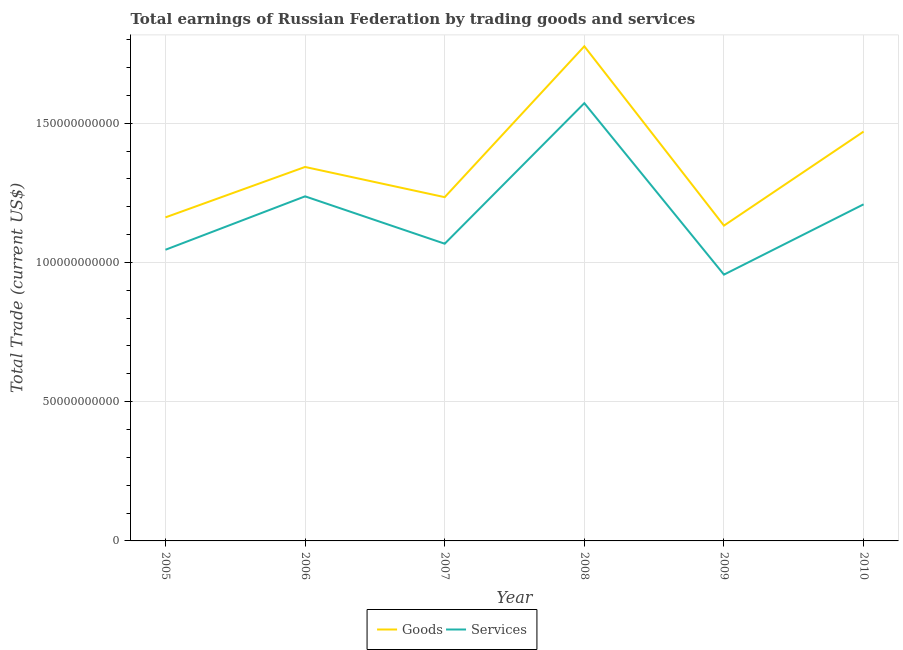How many different coloured lines are there?
Give a very brief answer. 2. Is the number of lines equal to the number of legend labels?
Keep it short and to the point. Yes. What is the amount earned by trading goods in 2010?
Provide a short and direct response. 1.47e+11. Across all years, what is the maximum amount earned by trading goods?
Give a very brief answer. 1.78e+11. Across all years, what is the minimum amount earned by trading goods?
Your response must be concise. 1.13e+11. What is the total amount earned by trading goods in the graph?
Make the answer very short. 8.12e+11. What is the difference between the amount earned by trading goods in 2007 and that in 2010?
Offer a terse response. -2.35e+1. What is the difference between the amount earned by trading goods in 2006 and the amount earned by trading services in 2010?
Keep it short and to the point. 1.34e+1. What is the average amount earned by trading services per year?
Make the answer very short. 1.18e+11. In the year 2010, what is the difference between the amount earned by trading services and amount earned by trading goods?
Your answer should be very brief. -2.61e+1. In how many years, is the amount earned by trading services greater than 90000000000 US$?
Provide a short and direct response. 6. What is the ratio of the amount earned by trading services in 2005 to that in 2007?
Keep it short and to the point. 0.98. Is the amount earned by trading goods in 2005 less than that in 2006?
Ensure brevity in your answer.  Yes. Is the difference between the amount earned by trading services in 2005 and 2009 greater than the difference between the amount earned by trading goods in 2005 and 2009?
Your response must be concise. Yes. What is the difference between the highest and the second highest amount earned by trading goods?
Keep it short and to the point. 3.06e+1. What is the difference between the highest and the lowest amount earned by trading goods?
Make the answer very short. 6.44e+1. In how many years, is the amount earned by trading services greater than the average amount earned by trading services taken over all years?
Your answer should be very brief. 3. Is the sum of the amount earned by trading goods in 2005 and 2008 greater than the maximum amount earned by trading services across all years?
Keep it short and to the point. Yes. Does the amount earned by trading services monotonically increase over the years?
Your response must be concise. No. How many lines are there?
Offer a very short reply. 2. What is the difference between two consecutive major ticks on the Y-axis?
Offer a very short reply. 5.00e+1. Does the graph contain any zero values?
Make the answer very short. No. Does the graph contain grids?
Provide a short and direct response. Yes. How are the legend labels stacked?
Keep it short and to the point. Horizontal. What is the title of the graph?
Offer a terse response. Total earnings of Russian Federation by trading goods and services. What is the label or title of the X-axis?
Provide a succinct answer. Year. What is the label or title of the Y-axis?
Your response must be concise. Total Trade (current US$). What is the Total Trade (current US$) of Goods in 2005?
Your answer should be compact. 1.16e+11. What is the Total Trade (current US$) of Services in 2005?
Ensure brevity in your answer.  1.05e+11. What is the Total Trade (current US$) in Goods in 2006?
Provide a short and direct response. 1.34e+11. What is the Total Trade (current US$) of Services in 2006?
Make the answer very short. 1.24e+11. What is the Total Trade (current US$) in Goods in 2007?
Your response must be concise. 1.23e+11. What is the Total Trade (current US$) of Services in 2007?
Make the answer very short. 1.07e+11. What is the Total Trade (current US$) in Goods in 2008?
Provide a succinct answer. 1.78e+11. What is the Total Trade (current US$) in Services in 2008?
Offer a very short reply. 1.57e+11. What is the Total Trade (current US$) in Goods in 2009?
Your answer should be very brief. 1.13e+11. What is the Total Trade (current US$) in Services in 2009?
Keep it short and to the point. 9.56e+1. What is the Total Trade (current US$) of Goods in 2010?
Provide a short and direct response. 1.47e+11. What is the Total Trade (current US$) of Services in 2010?
Offer a very short reply. 1.21e+11. Across all years, what is the maximum Total Trade (current US$) of Goods?
Your response must be concise. 1.78e+11. Across all years, what is the maximum Total Trade (current US$) of Services?
Your answer should be compact. 1.57e+11. Across all years, what is the minimum Total Trade (current US$) of Goods?
Keep it short and to the point. 1.13e+11. Across all years, what is the minimum Total Trade (current US$) in Services?
Provide a short and direct response. 9.56e+1. What is the total Total Trade (current US$) of Goods in the graph?
Offer a terse response. 8.12e+11. What is the total Total Trade (current US$) in Services in the graph?
Your answer should be compact. 7.09e+11. What is the difference between the Total Trade (current US$) in Goods in 2005 and that in 2006?
Your response must be concise. -1.81e+1. What is the difference between the Total Trade (current US$) in Services in 2005 and that in 2006?
Provide a short and direct response. -1.92e+1. What is the difference between the Total Trade (current US$) of Goods in 2005 and that in 2007?
Give a very brief answer. -7.26e+09. What is the difference between the Total Trade (current US$) of Services in 2005 and that in 2007?
Keep it short and to the point. -2.17e+09. What is the difference between the Total Trade (current US$) of Goods in 2005 and that in 2008?
Your answer should be compact. -6.14e+1. What is the difference between the Total Trade (current US$) in Services in 2005 and that in 2008?
Provide a short and direct response. -5.26e+1. What is the difference between the Total Trade (current US$) in Goods in 2005 and that in 2009?
Offer a very short reply. 2.95e+09. What is the difference between the Total Trade (current US$) in Services in 2005 and that in 2009?
Keep it short and to the point. 8.93e+09. What is the difference between the Total Trade (current US$) of Goods in 2005 and that in 2010?
Provide a short and direct response. -3.08e+1. What is the difference between the Total Trade (current US$) of Services in 2005 and that in 2010?
Offer a terse response. -1.63e+1. What is the difference between the Total Trade (current US$) in Goods in 2006 and that in 2007?
Ensure brevity in your answer.  1.08e+1. What is the difference between the Total Trade (current US$) in Services in 2006 and that in 2007?
Your response must be concise. 1.70e+1. What is the difference between the Total Trade (current US$) in Goods in 2006 and that in 2008?
Provide a succinct answer. -4.33e+1. What is the difference between the Total Trade (current US$) of Services in 2006 and that in 2008?
Give a very brief answer. -3.35e+1. What is the difference between the Total Trade (current US$) of Goods in 2006 and that in 2009?
Offer a terse response. 2.11e+1. What is the difference between the Total Trade (current US$) in Services in 2006 and that in 2009?
Make the answer very short. 2.81e+1. What is the difference between the Total Trade (current US$) in Goods in 2006 and that in 2010?
Your answer should be very brief. -1.27e+1. What is the difference between the Total Trade (current US$) of Services in 2006 and that in 2010?
Make the answer very short. 2.86e+09. What is the difference between the Total Trade (current US$) of Goods in 2007 and that in 2008?
Make the answer very short. -5.42e+1. What is the difference between the Total Trade (current US$) in Services in 2007 and that in 2008?
Offer a terse response. -5.05e+1. What is the difference between the Total Trade (current US$) of Goods in 2007 and that in 2009?
Your answer should be very brief. 1.02e+1. What is the difference between the Total Trade (current US$) in Services in 2007 and that in 2009?
Your answer should be very brief. 1.11e+1. What is the difference between the Total Trade (current US$) of Goods in 2007 and that in 2010?
Offer a very short reply. -2.35e+1. What is the difference between the Total Trade (current US$) in Services in 2007 and that in 2010?
Provide a short and direct response. -1.41e+1. What is the difference between the Total Trade (current US$) in Goods in 2008 and that in 2009?
Keep it short and to the point. 6.44e+1. What is the difference between the Total Trade (current US$) of Services in 2008 and that in 2009?
Your response must be concise. 6.16e+1. What is the difference between the Total Trade (current US$) in Goods in 2008 and that in 2010?
Make the answer very short. 3.06e+1. What is the difference between the Total Trade (current US$) in Services in 2008 and that in 2010?
Your answer should be very brief. 3.63e+1. What is the difference between the Total Trade (current US$) of Goods in 2009 and that in 2010?
Keep it short and to the point. -3.38e+1. What is the difference between the Total Trade (current US$) of Services in 2009 and that in 2010?
Your answer should be very brief. -2.52e+1. What is the difference between the Total Trade (current US$) of Goods in 2005 and the Total Trade (current US$) of Services in 2006?
Offer a terse response. -7.56e+09. What is the difference between the Total Trade (current US$) of Goods in 2005 and the Total Trade (current US$) of Services in 2007?
Ensure brevity in your answer.  9.46e+09. What is the difference between the Total Trade (current US$) of Goods in 2005 and the Total Trade (current US$) of Services in 2008?
Give a very brief answer. -4.10e+1. What is the difference between the Total Trade (current US$) in Goods in 2005 and the Total Trade (current US$) in Services in 2009?
Keep it short and to the point. 2.06e+1. What is the difference between the Total Trade (current US$) in Goods in 2005 and the Total Trade (current US$) in Services in 2010?
Keep it short and to the point. -4.69e+09. What is the difference between the Total Trade (current US$) of Goods in 2006 and the Total Trade (current US$) of Services in 2007?
Your response must be concise. 2.76e+1. What is the difference between the Total Trade (current US$) of Goods in 2006 and the Total Trade (current US$) of Services in 2008?
Offer a terse response. -2.29e+1. What is the difference between the Total Trade (current US$) of Goods in 2006 and the Total Trade (current US$) of Services in 2009?
Make the answer very short. 3.87e+1. What is the difference between the Total Trade (current US$) in Goods in 2006 and the Total Trade (current US$) in Services in 2010?
Ensure brevity in your answer.  1.34e+1. What is the difference between the Total Trade (current US$) of Goods in 2007 and the Total Trade (current US$) of Services in 2008?
Your answer should be compact. -3.38e+1. What is the difference between the Total Trade (current US$) of Goods in 2007 and the Total Trade (current US$) of Services in 2009?
Offer a terse response. 2.78e+1. What is the difference between the Total Trade (current US$) of Goods in 2007 and the Total Trade (current US$) of Services in 2010?
Your response must be concise. 2.57e+09. What is the difference between the Total Trade (current US$) of Goods in 2008 and the Total Trade (current US$) of Services in 2009?
Your answer should be compact. 8.20e+1. What is the difference between the Total Trade (current US$) in Goods in 2008 and the Total Trade (current US$) in Services in 2010?
Offer a terse response. 5.68e+1. What is the difference between the Total Trade (current US$) of Goods in 2009 and the Total Trade (current US$) of Services in 2010?
Keep it short and to the point. -7.64e+09. What is the average Total Trade (current US$) of Goods per year?
Provide a succinct answer. 1.35e+11. What is the average Total Trade (current US$) in Services per year?
Offer a terse response. 1.18e+11. In the year 2005, what is the difference between the Total Trade (current US$) of Goods and Total Trade (current US$) of Services?
Your response must be concise. 1.16e+1. In the year 2006, what is the difference between the Total Trade (current US$) of Goods and Total Trade (current US$) of Services?
Offer a terse response. 1.06e+1. In the year 2007, what is the difference between the Total Trade (current US$) of Goods and Total Trade (current US$) of Services?
Offer a very short reply. 1.67e+1. In the year 2008, what is the difference between the Total Trade (current US$) of Goods and Total Trade (current US$) of Services?
Offer a terse response. 2.04e+1. In the year 2009, what is the difference between the Total Trade (current US$) in Goods and Total Trade (current US$) in Services?
Keep it short and to the point. 1.76e+1. In the year 2010, what is the difference between the Total Trade (current US$) in Goods and Total Trade (current US$) in Services?
Provide a short and direct response. 2.61e+1. What is the ratio of the Total Trade (current US$) of Goods in 2005 to that in 2006?
Keep it short and to the point. 0.87. What is the ratio of the Total Trade (current US$) of Services in 2005 to that in 2006?
Provide a succinct answer. 0.84. What is the ratio of the Total Trade (current US$) in Services in 2005 to that in 2007?
Offer a very short reply. 0.98. What is the ratio of the Total Trade (current US$) of Goods in 2005 to that in 2008?
Your response must be concise. 0.65. What is the ratio of the Total Trade (current US$) of Services in 2005 to that in 2008?
Your answer should be very brief. 0.67. What is the ratio of the Total Trade (current US$) of Goods in 2005 to that in 2009?
Your answer should be very brief. 1.03. What is the ratio of the Total Trade (current US$) in Services in 2005 to that in 2009?
Your response must be concise. 1.09. What is the ratio of the Total Trade (current US$) of Goods in 2005 to that in 2010?
Your answer should be very brief. 0.79. What is the ratio of the Total Trade (current US$) in Services in 2005 to that in 2010?
Make the answer very short. 0.86. What is the ratio of the Total Trade (current US$) in Goods in 2006 to that in 2007?
Provide a succinct answer. 1.09. What is the ratio of the Total Trade (current US$) of Services in 2006 to that in 2007?
Offer a terse response. 1.16. What is the ratio of the Total Trade (current US$) of Goods in 2006 to that in 2008?
Your response must be concise. 0.76. What is the ratio of the Total Trade (current US$) in Services in 2006 to that in 2008?
Keep it short and to the point. 0.79. What is the ratio of the Total Trade (current US$) in Goods in 2006 to that in 2009?
Offer a terse response. 1.19. What is the ratio of the Total Trade (current US$) in Services in 2006 to that in 2009?
Offer a terse response. 1.29. What is the ratio of the Total Trade (current US$) in Goods in 2006 to that in 2010?
Your answer should be very brief. 0.91. What is the ratio of the Total Trade (current US$) in Services in 2006 to that in 2010?
Provide a succinct answer. 1.02. What is the ratio of the Total Trade (current US$) in Goods in 2007 to that in 2008?
Offer a terse response. 0.69. What is the ratio of the Total Trade (current US$) of Services in 2007 to that in 2008?
Offer a terse response. 0.68. What is the ratio of the Total Trade (current US$) in Goods in 2007 to that in 2009?
Your answer should be compact. 1.09. What is the ratio of the Total Trade (current US$) of Services in 2007 to that in 2009?
Provide a short and direct response. 1.12. What is the ratio of the Total Trade (current US$) in Goods in 2007 to that in 2010?
Keep it short and to the point. 0.84. What is the ratio of the Total Trade (current US$) in Services in 2007 to that in 2010?
Provide a succinct answer. 0.88. What is the ratio of the Total Trade (current US$) in Goods in 2008 to that in 2009?
Offer a terse response. 1.57. What is the ratio of the Total Trade (current US$) of Services in 2008 to that in 2009?
Keep it short and to the point. 1.64. What is the ratio of the Total Trade (current US$) of Goods in 2008 to that in 2010?
Give a very brief answer. 1.21. What is the ratio of the Total Trade (current US$) in Services in 2008 to that in 2010?
Your answer should be compact. 1.3. What is the ratio of the Total Trade (current US$) of Goods in 2009 to that in 2010?
Make the answer very short. 0.77. What is the ratio of the Total Trade (current US$) of Services in 2009 to that in 2010?
Your response must be concise. 0.79. What is the difference between the highest and the second highest Total Trade (current US$) of Goods?
Provide a succinct answer. 3.06e+1. What is the difference between the highest and the second highest Total Trade (current US$) in Services?
Keep it short and to the point. 3.35e+1. What is the difference between the highest and the lowest Total Trade (current US$) of Goods?
Ensure brevity in your answer.  6.44e+1. What is the difference between the highest and the lowest Total Trade (current US$) in Services?
Your response must be concise. 6.16e+1. 